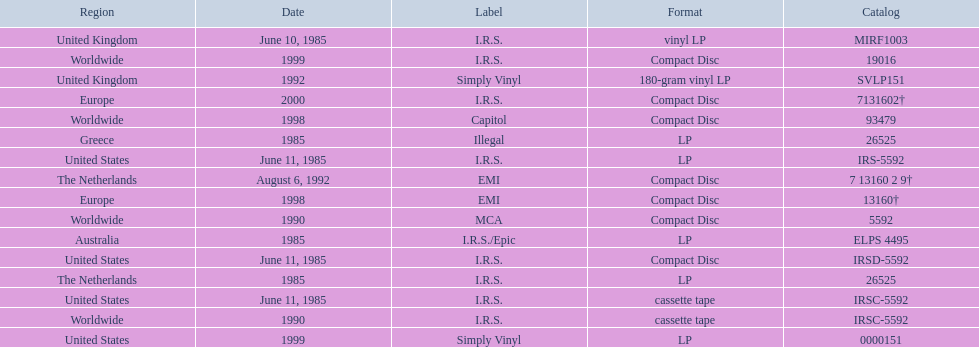Which year had the most releases? 1985. 